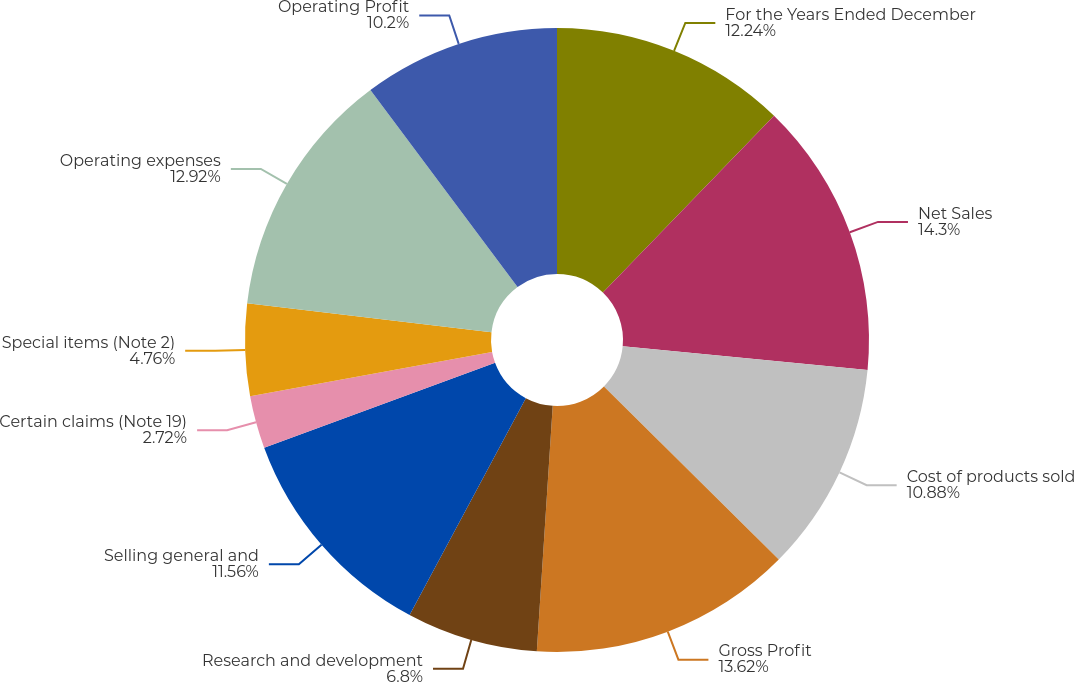<chart> <loc_0><loc_0><loc_500><loc_500><pie_chart><fcel>For the Years Ended December<fcel>Net Sales<fcel>Cost of products sold<fcel>Gross Profit<fcel>Research and development<fcel>Selling general and<fcel>Certain claims (Note 19)<fcel>Special items (Note 2)<fcel>Operating expenses<fcel>Operating Profit<nl><fcel>12.24%<fcel>14.29%<fcel>10.88%<fcel>13.61%<fcel>6.8%<fcel>11.56%<fcel>2.72%<fcel>4.76%<fcel>12.92%<fcel>10.2%<nl></chart> 